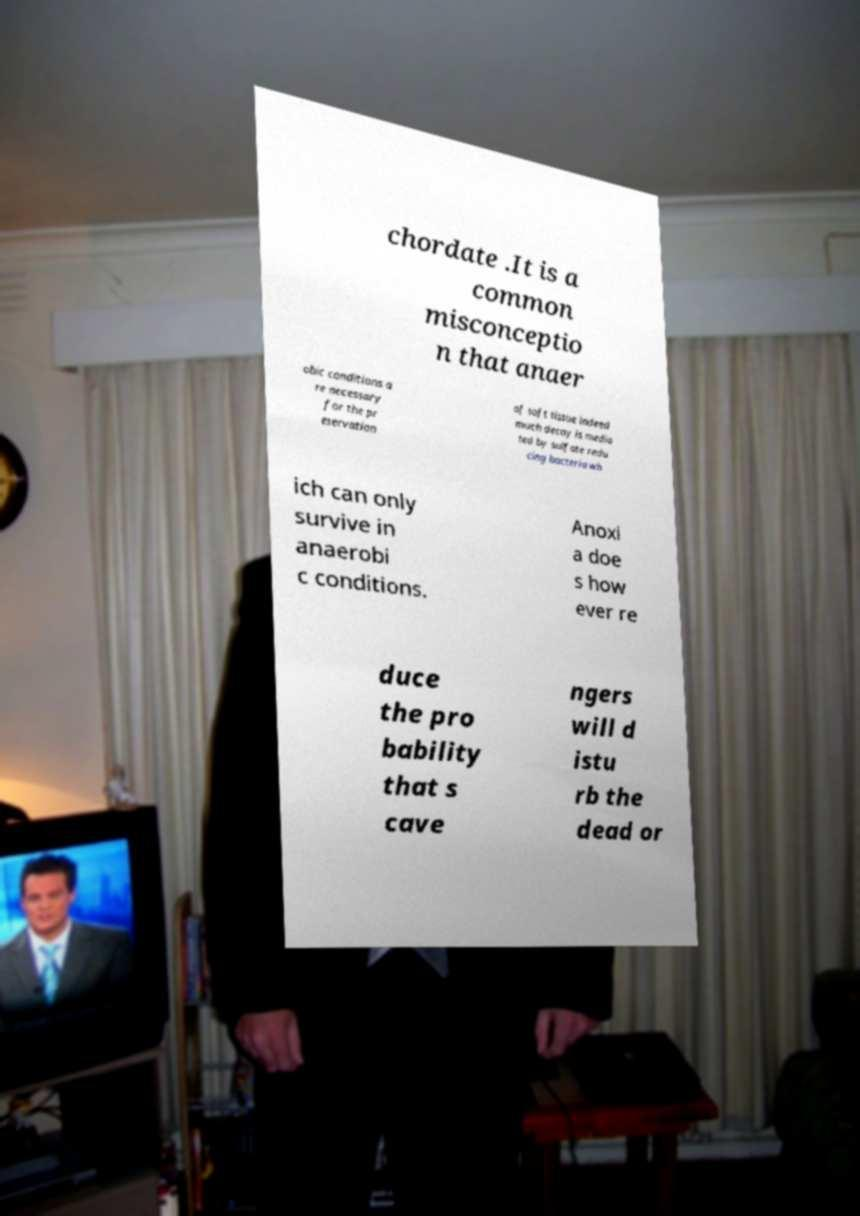I need the written content from this picture converted into text. Can you do that? chordate .It is a common misconceptio n that anaer obic conditions a re necessary for the pr eservation of soft tissue indeed much decay is media ted by sulfate redu cing bacteria wh ich can only survive in anaerobi c conditions. Anoxi a doe s how ever re duce the pro bability that s cave ngers will d istu rb the dead or 